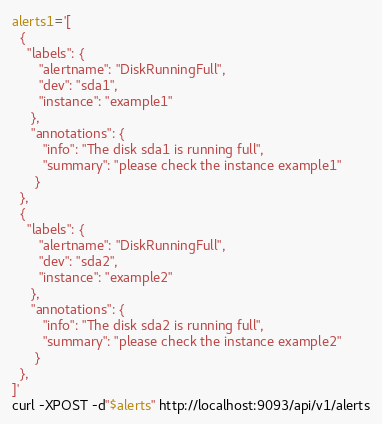Convert code to text. <code><loc_0><loc_0><loc_500><loc_500><_Bash_>alerts1='[
  {
    "labels": {
       "alertname": "DiskRunningFull",
       "dev": "sda1",
       "instance": "example1"
     },
     "annotations": {
        "info": "The disk sda1 is running full",
        "summary": "please check the instance example1"
      }
  },
  {
    "labels": {
       "alertname": "DiskRunningFull",
       "dev": "sda2",
       "instance": "example2"
     },
     "annotations": {
        "info": "The disk sda2 is running full",
        "summary": "please check the instance example2"
      }
  },
]'
curl -XPOST -d"$alerts" http://localhost:9093/api/v1/alerts
</code> 